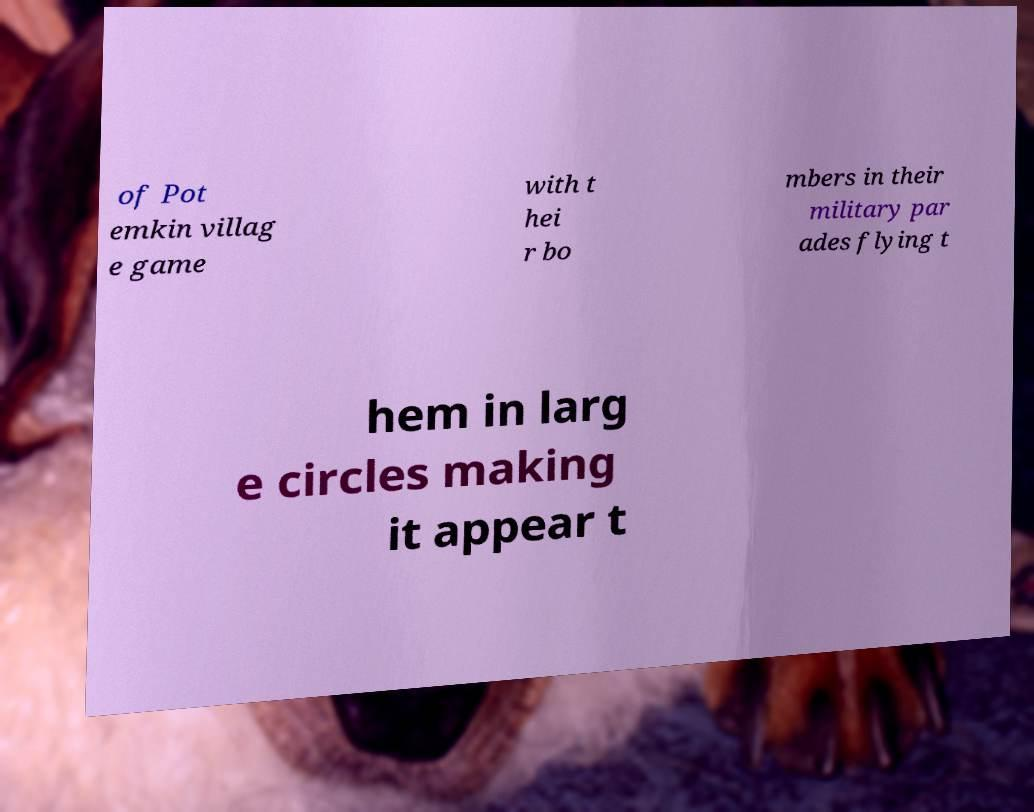I need the written content from this picture converted into text. Can you do that? of Pot emkin villag e game with t hei r bo mbers in their military par ades flying t hem in larg e circles making it appear t 